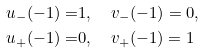Convert formula to latex. <formula><loc_0><loc_0><loc_500><loc_500>u _ { - } ( - 1 ) = & 1 , \quad v _ { - } ( - 1 ) = 0 , \\ u _ { + } ( - 1 ) = & 0 , \quad v _ { + } ( - 1 ) = 1</formula> 